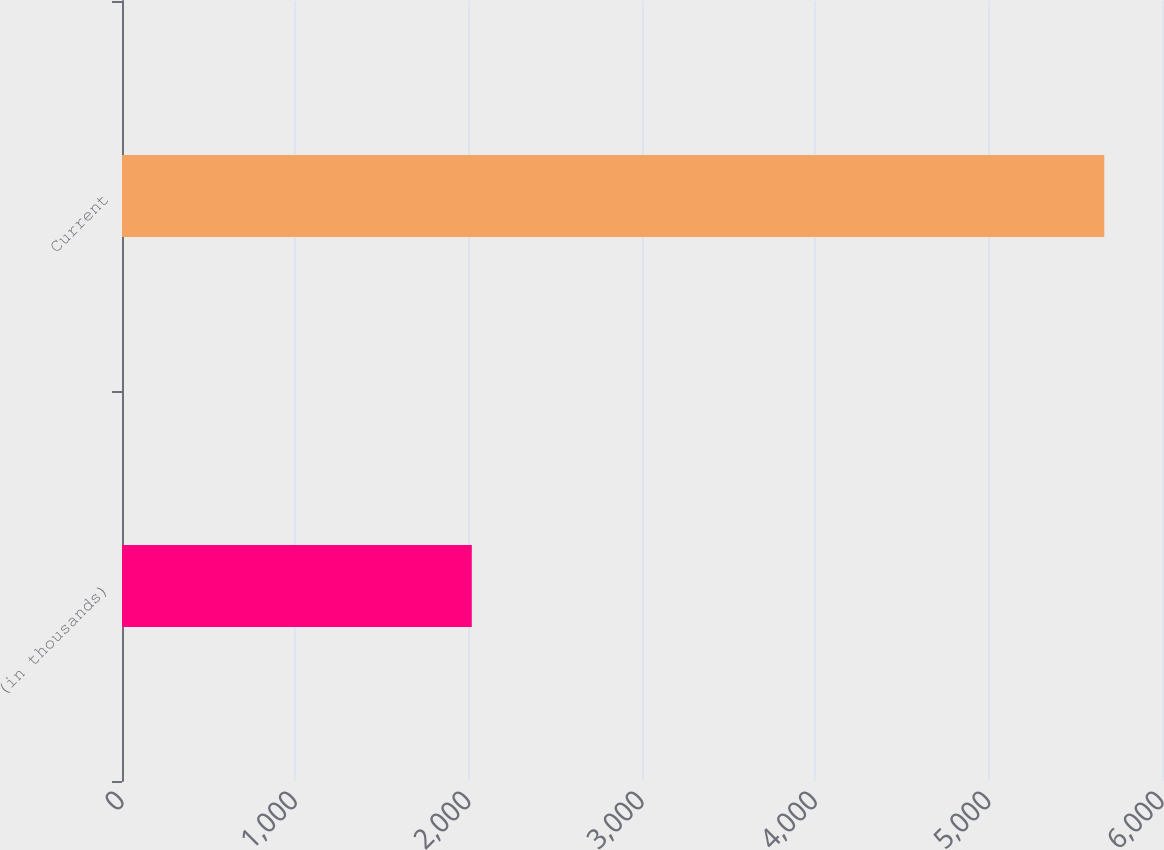<chart> <loc_0><loc_0><loc_500><loc_500><bar_chart><fcel>(in thousands)<fcel>Current<nl><fcel>2018<fcel>5667<nl></chart> 